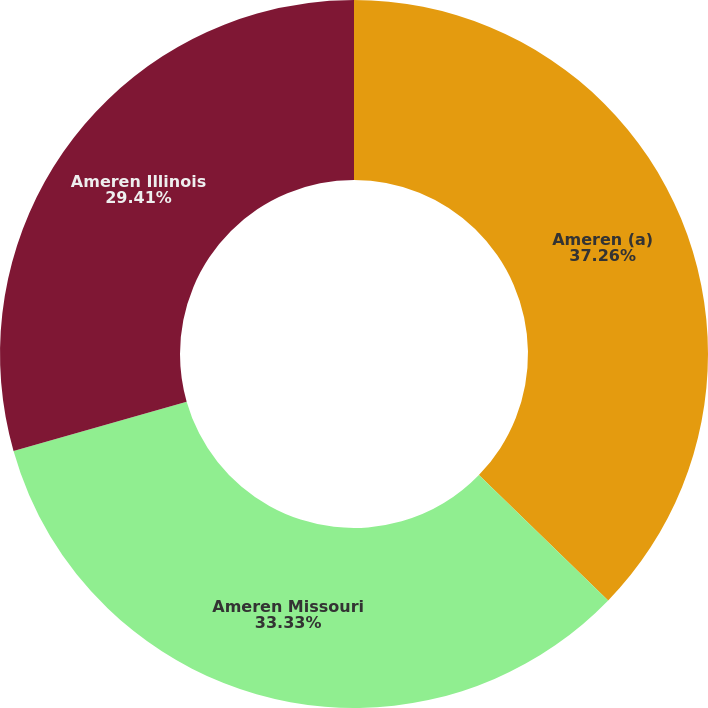<chart> <loc_0><loc_0><loc_500><loc_500><pie_chart><fcel>Ameren (a)<fcel>Ameren Missouri<fcel>Ameren Illinois<nl><fcel>37.25%<fcel>33.33%<fcel>29.41%<nl></chart> 